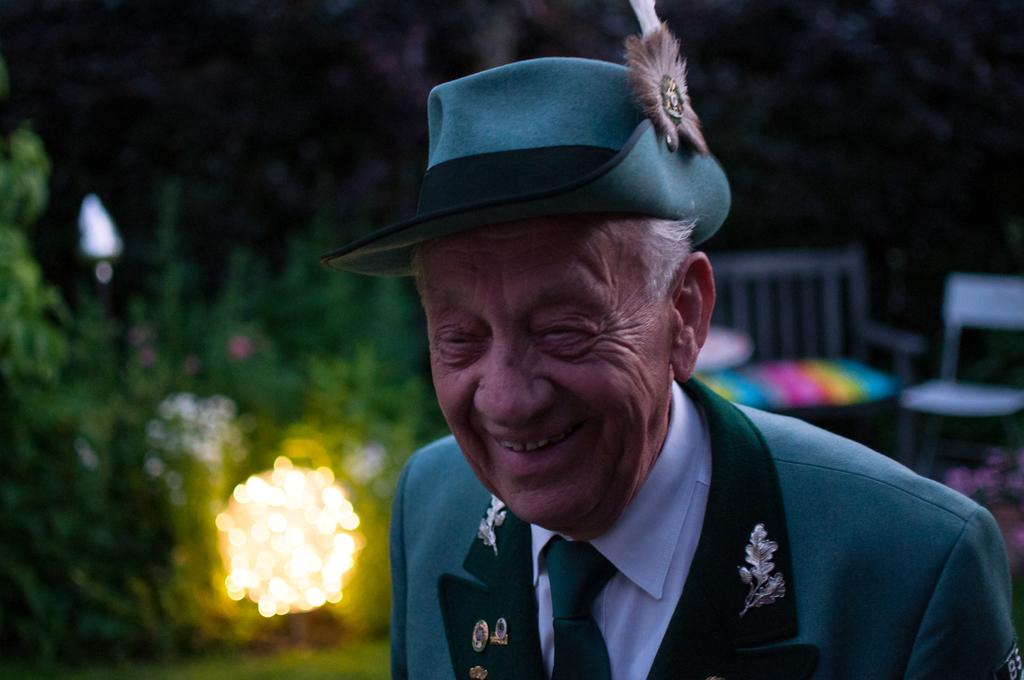Who is the main subject in the image? There is an old man in the image. What is the old man doing in the image? The old man is smiling in the image. What accessories is the old man wearing in the image? The old man is wearing a cap, a suit, a tie, and a shirt in the image. What can be seen in the background of the image? There are chairs and trees in the background of the image. How many ducks are sitting on the old man's lap in the image? There are no ducks present in the image. Who is the old man's friend in the image? The image only shows the old man, so there is no friend visible. 